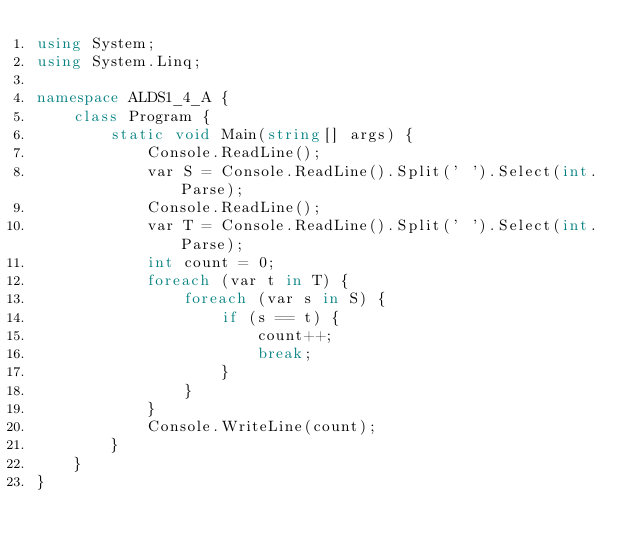<code> <loc_0><loc_0><loc_500><loc_500><_C#_>using System;
using System.Linq;

namespace ALDS1_4_A {
    class Program {
        static void Main(string[] args) {
            Console.ReadLine();
            var S = Console.ReadLine().Split(' ').Select(int.Parse);
            Console.ReadLine();
            var T = Console.ReadLine().Split(' ').Select(int.Parse);
            int count = 0;
            foreach (var t in T) {
                foreach (var s in S) {
                    if (s == t) {
                        count++;
                        break;
                    }
                }
            }
            Console.WriteLine(count);
        }
    }
}</code> 